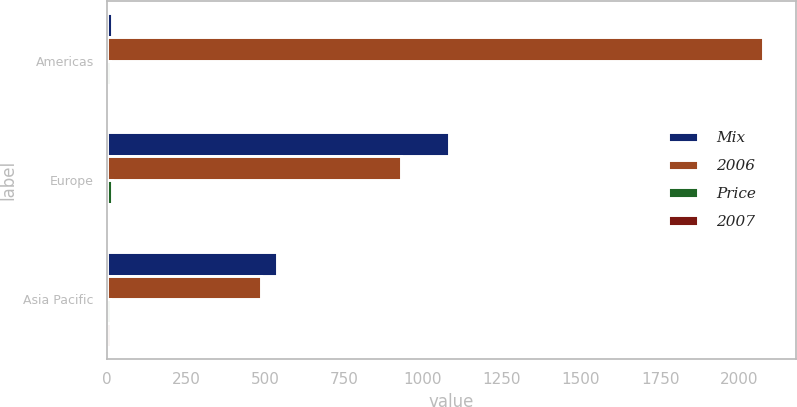Convert chart to OTSL. <chart><loc_0><loc_0><loc_500><loc_500><stacked_bar_chart><ecel><fcel>Americas<fcel>Europe<fcel>Asia Pacific<nl><fcel>Mix<fcel>16<fcel>1081<fcel>539.5<nl><fcel>2006<fcel>2076.5<fcel>931.1<fcel>487.8<nl><fcel>Price<fcel>10<fcel>16<fcel>11<nl><fcel>2007<fcel>8<fcel>8<fcel>9<nl></chart> 